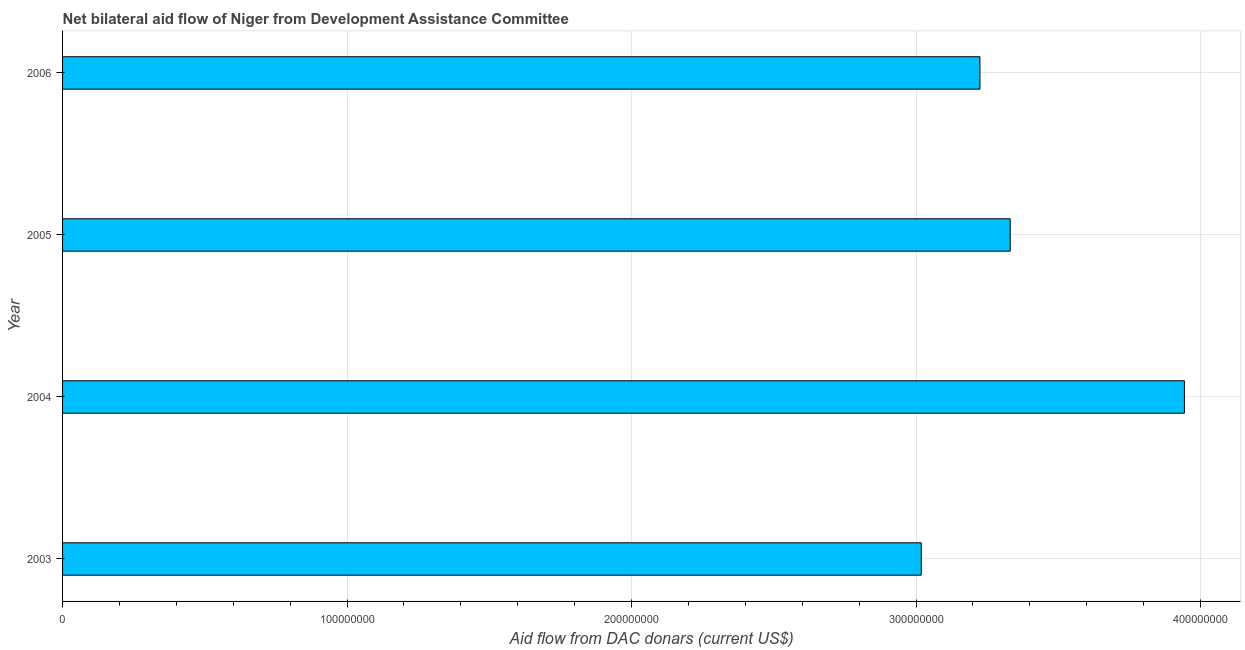Does the graph contain grids?
Your response must be concise. Yes. What is the title of the graph?
Provide a short and direct response. Net bilateral aid flow of Niger from Development Assistance Committee. What is the label or title of the X-axis?
Your response must be concise. Aid flow from DAC donars (current US$). What is the label or title of the Y-axis?
Provide a short and direct response. Year. What is the net bilateral aid flows from dac donors in 2003?
Offer a terse response. 3.02e+08. Across all years, what is the maximum net bilateral aid flows from dac donors?
Give a very brief answer. 3.94e+08. Across all years, what is the minimum net bilateral aid flows from dac donors?
Offer a very short reply. 3.02e+08. In which year was the net bilateral aid flows from dac donors maximum?
Offer a very short reply. 2004. In which year was the net bilateral aid flows from dac donors minimum?
Offer a terse response. 2003. What is the sum of the net bilateral aid flows from dac donors?
Keep it short and to the point. 1.35e+09. What is the difference between the net bilateral aid flows from dac donors in 2004 and 2005?
Provide a short and direct response. 6.12e+07. What is the average net bilateral aid flows from dac donors per year?
Ensure brevity in your answer.  3.38e+08. What is the median net bilateral aid flows from dac donors?
Provide a short and direct response. 3.28e+08. In how many years, is the net bilateral aid flows from dac donors greater than 380000000 US$?
Your answer should be compact. 1. What is the ratio of the net bilateral aid flows from dac donors in 2003 to that in 2005?
Provide a succinct answer. 0.91. Is the net bilateral aid flows from dac donors in 2003 less than that in 2006?
Make the answer very short. Yes. Is the difference between the net bilateral aid flows from dac donors in 2003 and 2005 greater than the difference between any two years?
Offer a terse response. No. What is the difference between the highest and the second highest net bilateral aid flows from dac donors?
Your response must be concise. 6.12e+07. Is the sum of the net bilateral aid flows from dac donors in 2005 and 2006 greater than the maximum net bilateral aid flows from dac donors across all years?
Provide a succinct answer. Yes. What is the difference between the highest and the lowest net bilateral aid flows from dac donors?
Offer a terse response. 9.25e+07. Are all the bars in the graph horizontal?
Ensure brevity in your answer.  Yes. How many years are there in the graph?
Ensure brevity in your answer.  4. What is the Aid flow from DAC donars (current US$) of 2003?
Make the answer very short. 3.02e+08. What is the Aid flow from DAC donars (current US$) of 2004?
Offer a terse response. 3.94e+08. What is the Aid flow from DAC donars (current US$) in 2005?
Make the answer very short. 3.33e+08. What is the Aid flow from DAC donars (current US$) in 2006?
Keep it short and to the point. 3.22e+08. What is the difference between the Aid flow from DAC donars (current US$) in 2003 and 2004?
Your answer should be compact. -9.25e+07. What is the difference between the Aid flow from DAC donars (current US$) in 2003 and 2005?
Provide a succinct answer. -3.13e+07. What is the difference between the Aid flow from DAC donars (current US$) in 2003 and 2006?
Your answer should be very brief. -2.06e+07. What is the difference between the Aid flow from DAC donars (current US$) in 2004 and 2005?
Provide a short and direct response. 6.12e+07. What is the difference between the Aid flow from DAC donars (current US$) in 2004 and 2006?
Provide a succinct answer. 7.19e+07. What is the difference between the Aid flow from DAC donars (current US$) in 2005 and 2006?
Ensure brevity in your answer.  1.06e+07. What is the ratio of the Aid flow from DAC donars (current US$) in 2003 to that in 2004?
Your answer should be compact. 0.77. What is the ratio of the Aid flow from DAC donars (current US$) in 2003 to that in 2005?
Your answer should be compact. 0.91. What is the ratio of the Aid flow from DAC donars (current US$) in 2003 to that in 2006?
Make the answer very short. 0.94. What is the ratio of the Aid flow from DAC donars (current US$) in 2004 to that in 2005?
Offer a terse response. 1.18. What is the ratio of the Aid flow from DAC donars (current US$) in 2004 to that in 2006?
Provide a succinct answer. 1.22. What is the ratio of the Aid flow from DAC donars (current US$) in 2005 to that in 2006?
Your answer should be very brief. 1.03. 